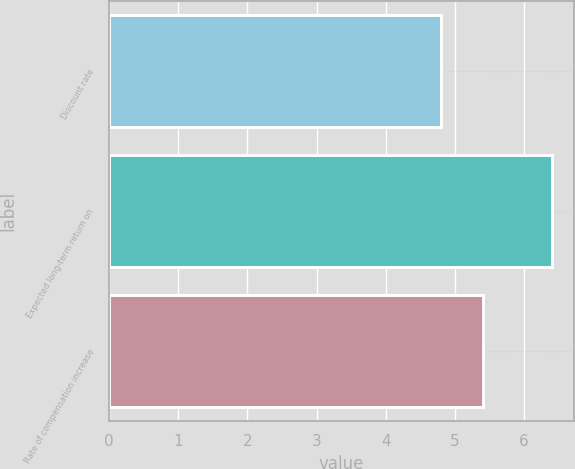Convert chart. <chart><loc_0><loc_0><loc_500><loc_500><bar_chart><fcel>Discount rate<fcel>Expected long-term return on<fcel>Rate of compensation increase<nl><fcel>4.8<fcel>6.4<fcel>5.4<nl></chart> 